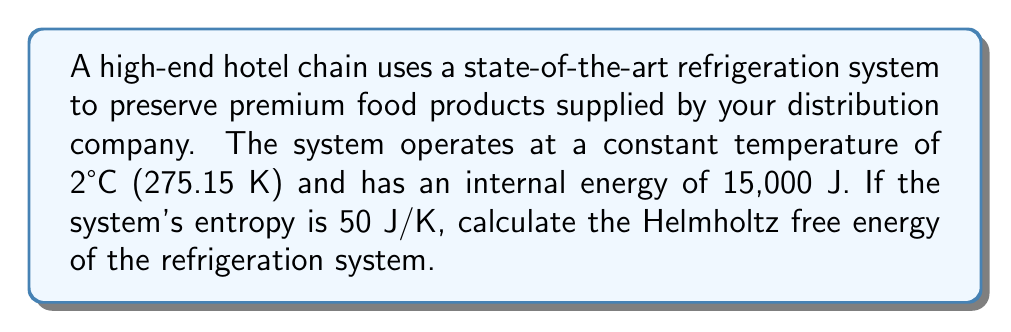Could you help me with this problem? To solve this problem, we'll use the definition of Helmholtz free energy and the given information:

1. The Helmholtz free energy (F) is defined as:
   $$F = U - TS$$
   where:
   - F is the Helmholtz free energy
   - U is the internal energy
   - T is the temperature
   - S is the entropy

2. We are given:
   - U = 15,000 J
   - T = 275.15 K (2°C converted to Kelvin)
   - S = 50 J/K

3. Let's substitute these values into the equation:
   $$F = 15,000 \text{ J} - (275.15 \text{ K})(50 \text{ J/K})$$

4. Simplify:
   $$F = 15,000 \text{ J} - 13,757.5 \text{ J}$$

5. Calculate the final result:
   $$F = 1,242.5 \text{ J}$$

Therefore, the Helmholtz free energy of the refrigeration system is 1,242.5 J.
Answer: 1,242.5 J 